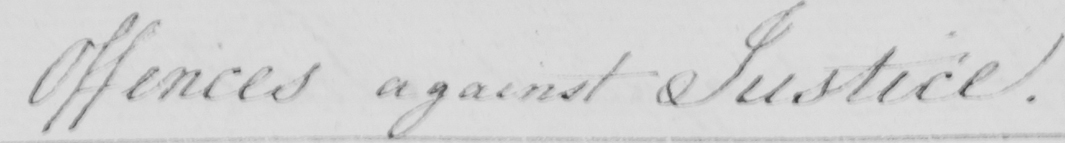What is written in this line of handwriting? Offences against Justice . 